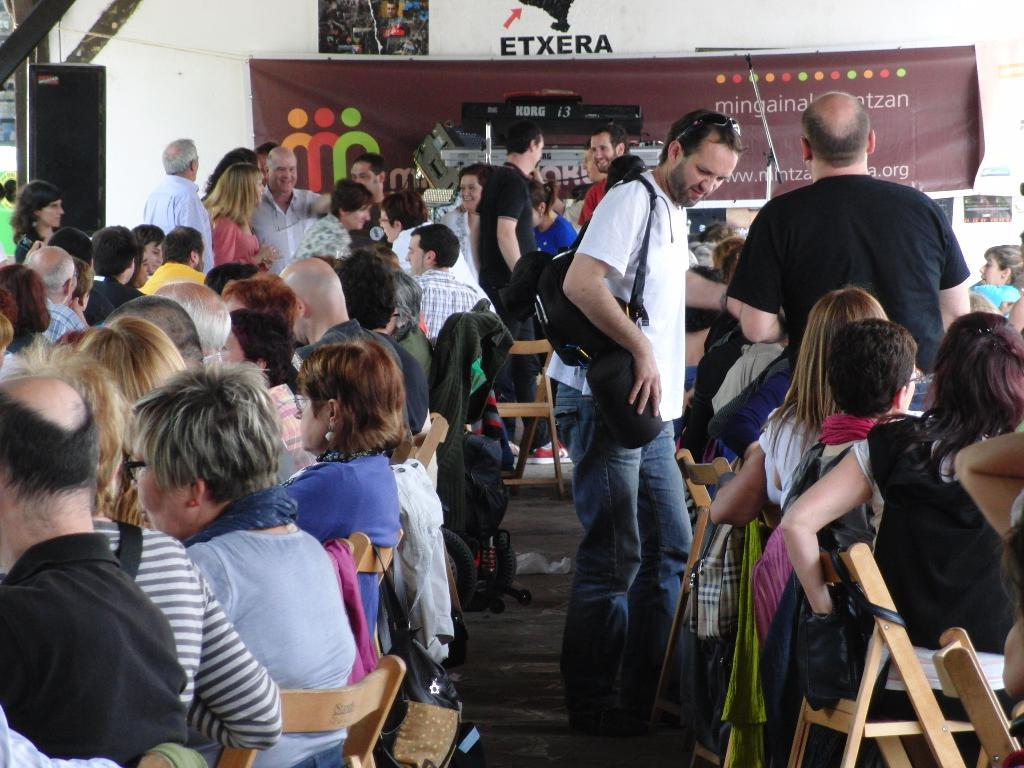How many people are in the image? There is a group of people in the image. What are the people in the image doing? Some people are standing, while others are sitting on chairs. What can be seen in the background of the image? There is a banner, a speaker, and posters attached to the wall in the background of the image. What type of food is being served on the road in the image? There is no road or food present in the image. Is there a trampoline visible in the image? There is no trampoline present in the image. 